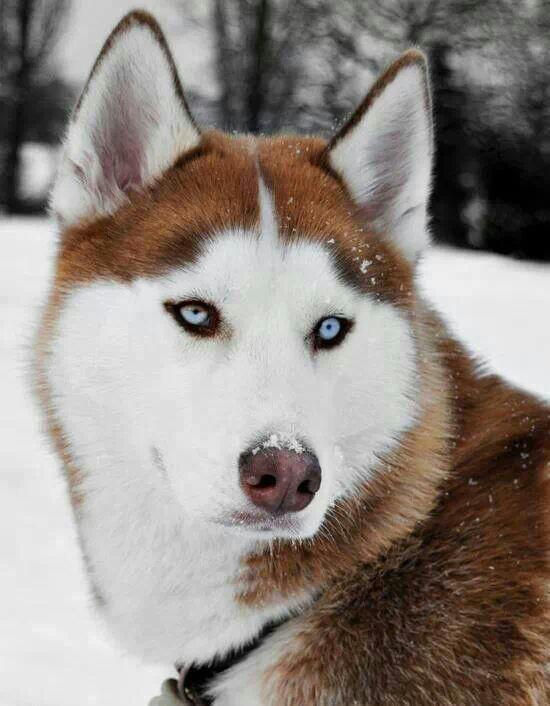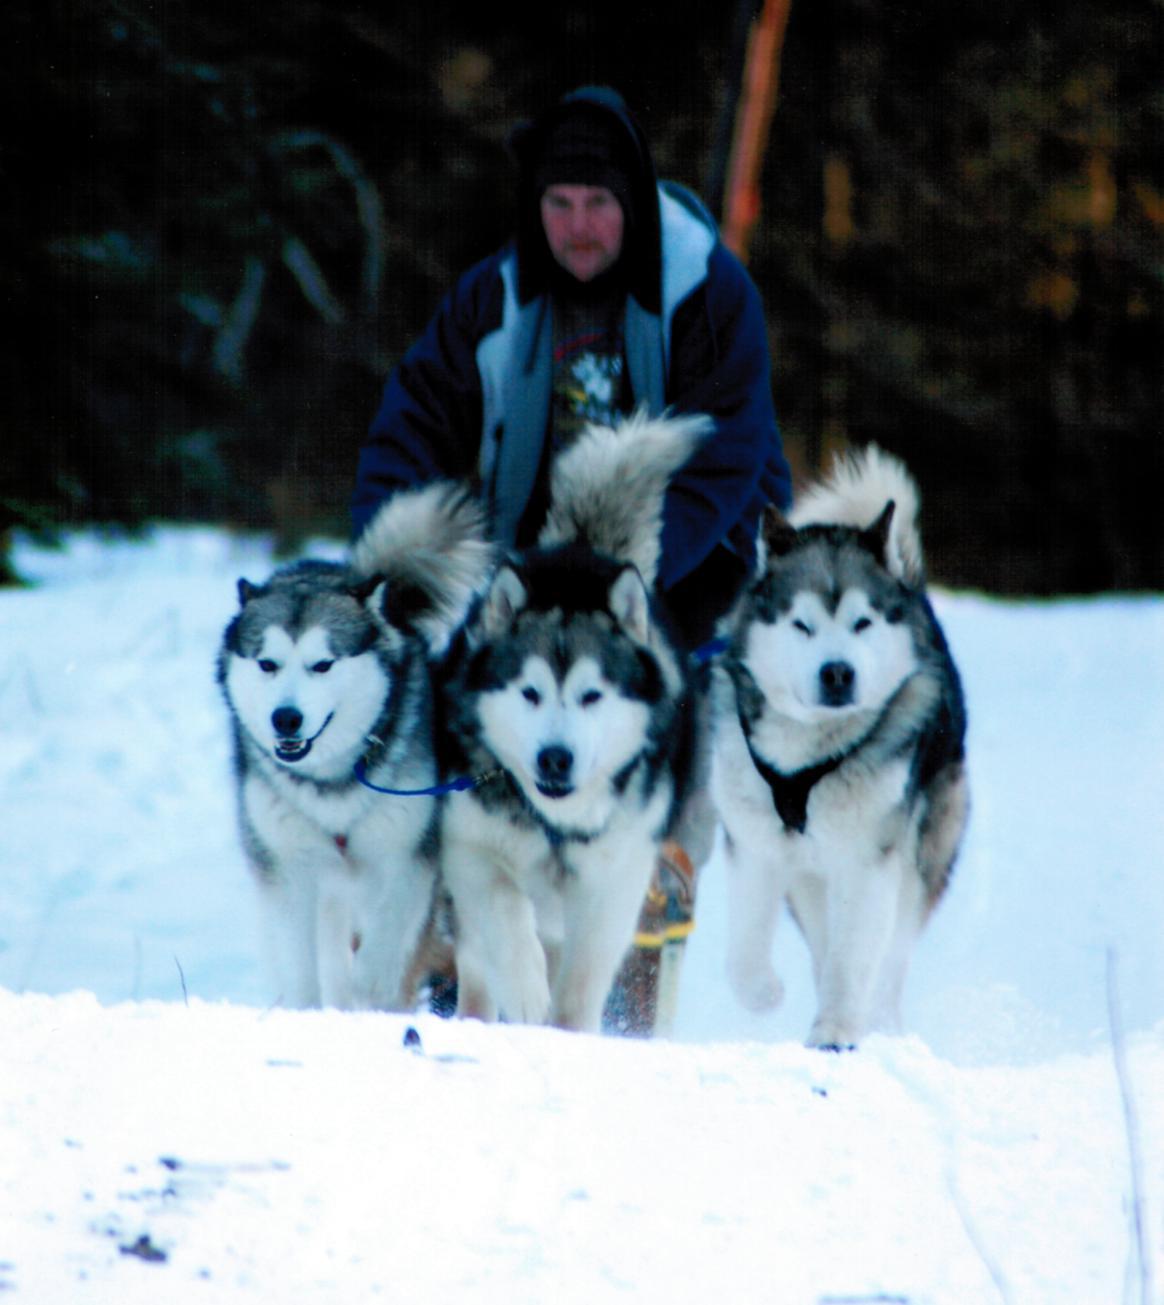The first image is the image on the left, the second image is the image on the right. For the images displayed, is the sentence "The right and left image contains the same number of dogs huskeys." factually correct? Answer yes or no. No. 